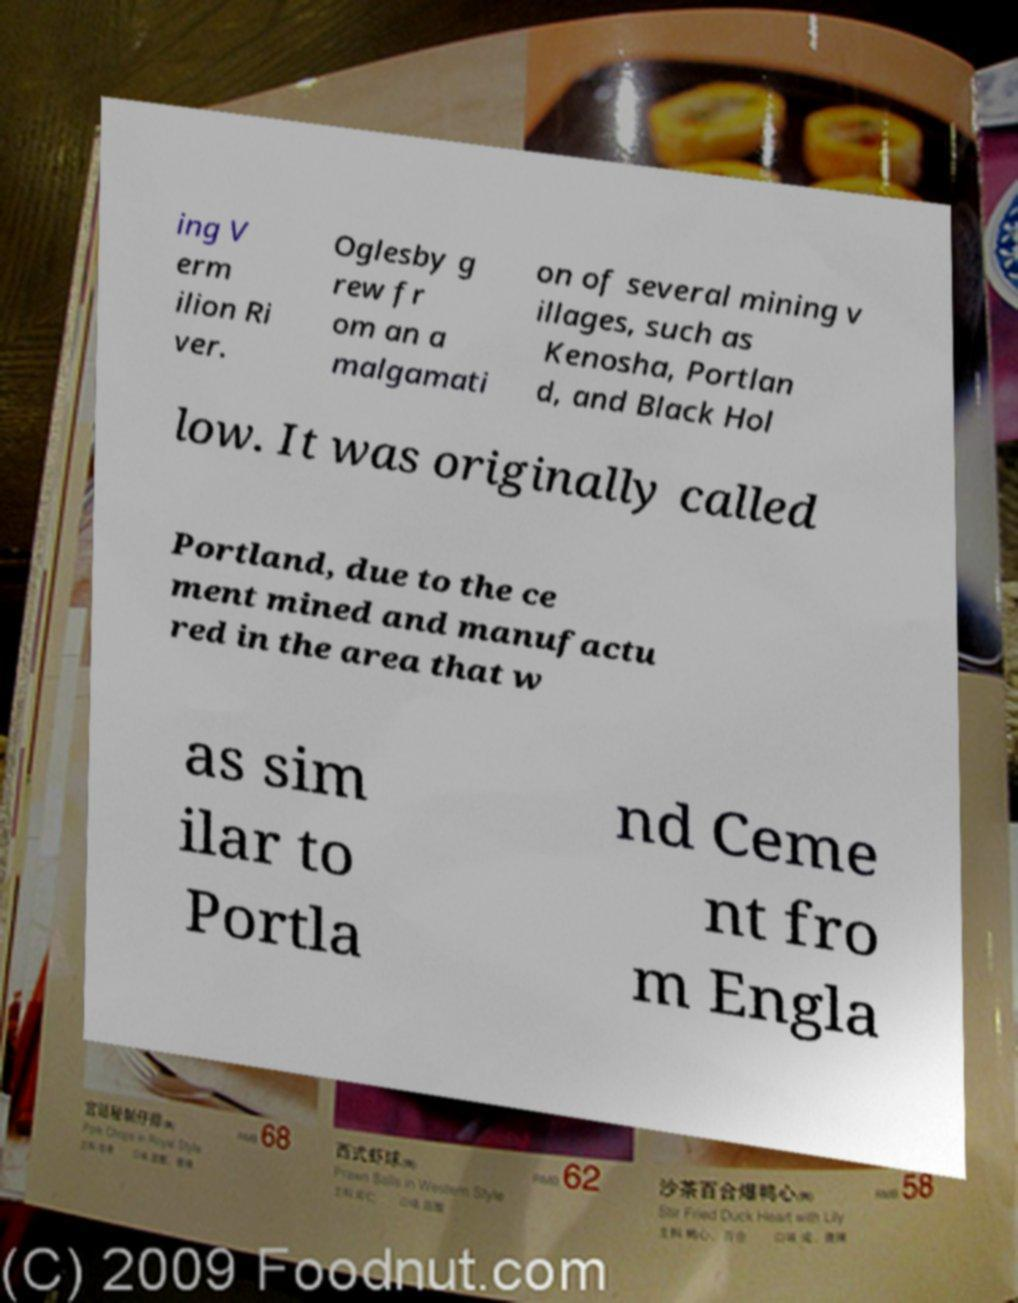Could you extract and type out the text from this image? ing V erm ilion Ri ver. Oglesby g rew fr om an a malgamati on of several mining v illages, such as Kenosha, Portlan d, and Black Hol low. It was originally called Portland, due to the ce ment mined and manufactu red in the area that w as sim ilar to Portla nd Ceme nt fro m Engla 